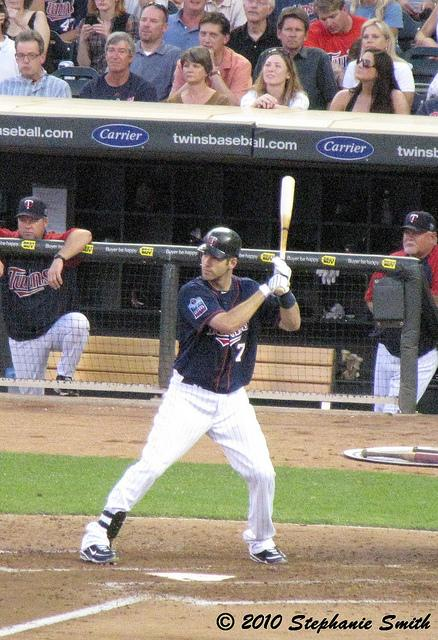What is the name of the batter? Please explain your reasoning. joe mauer. Joe mauer plays for this team. 